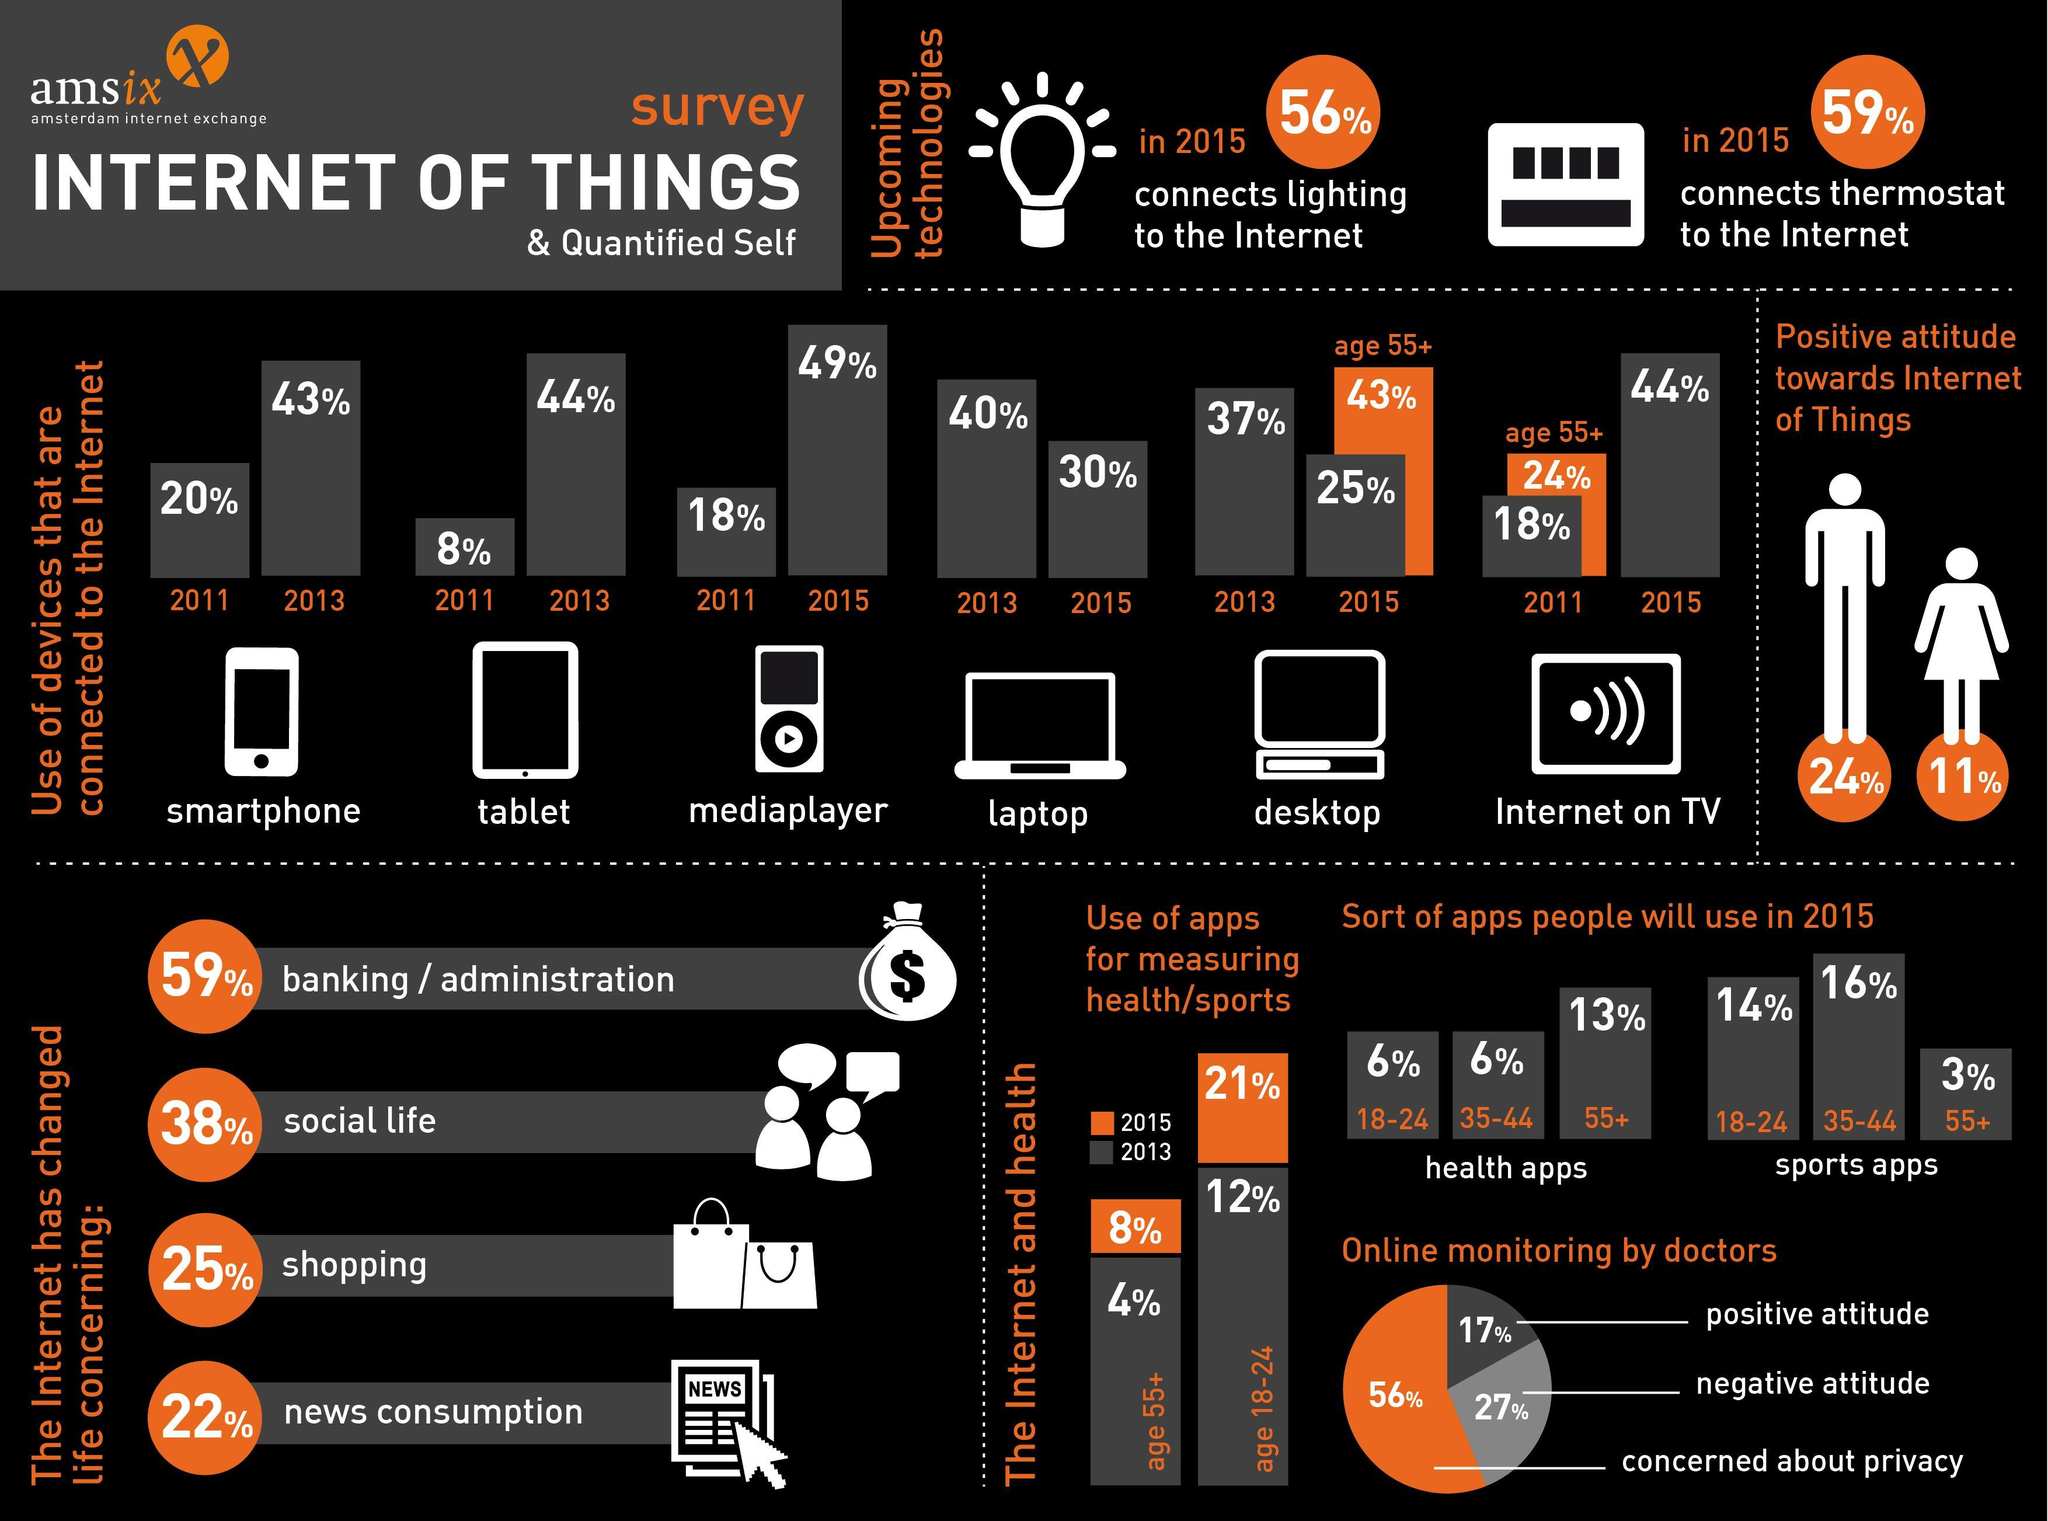What is total percentage of men and women who were pro-IoT?
Answer the question with a short phrase. 35% Which apps were more popular among the age group 35-44, health apps, sports apps, or productivity apps? sports apps What percentage of people above 55 years used health apps? 8% What percentage of people above 55 years use desktops connected to internet? 43% Which device was extensively used to connect to the internet in 2015? mediaplayer What was the percentile decline in usage of laptops from 2013 to 2015 ? 10% What percentage of people between 18-24 years used health apps? 21% What percentage of people above 55 years use TVs connected to internet? 24% 